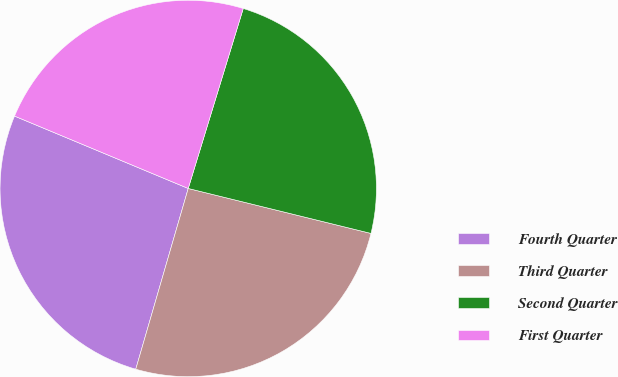<chart> <loc_0><loc_0><loc_500><loc_500><pie_chart><fcel>Fourth Quarter<fcel>Third Quarter<fcel>Second Quarter<fcel>First Quarter<nl><fcel>26.79%<fcel>25.66%<fcel>24.12%<fcel>23.44%<nl></chart> 